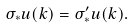Convert formula to latex. <formula><loc_0><loc_0><loc_500><loc_500>\sigma _ { * } u ( k ) = \sigma ^ { \prime } _ { * } u ( k ) .</formula> 